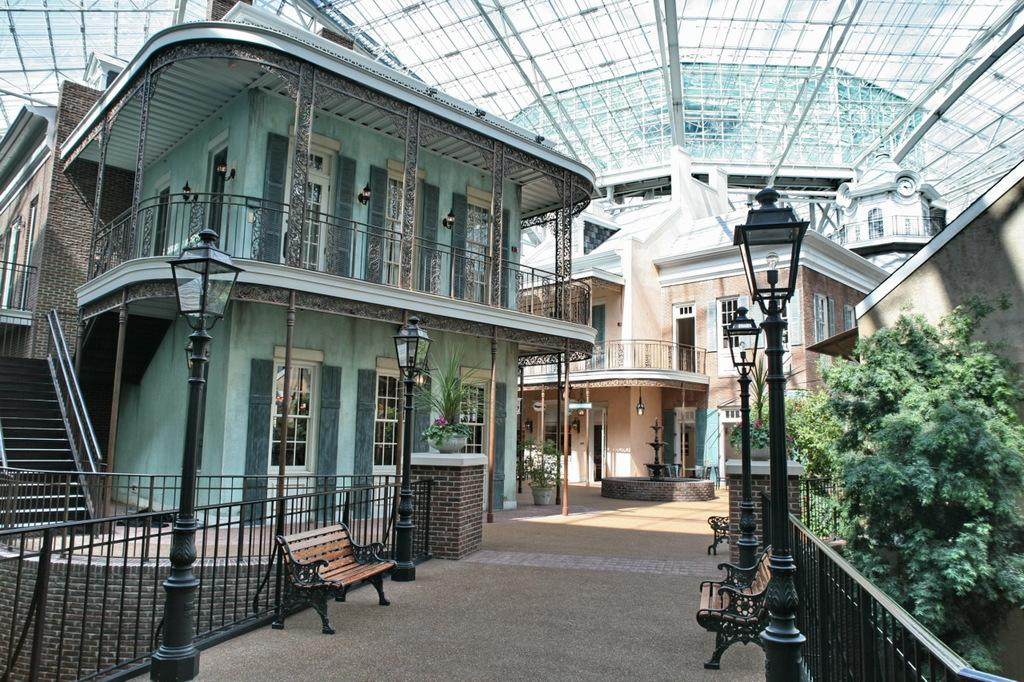What type of seating is visible in the image? There are benches in the image. What structures can be seen on the ground in the image? There are poles on the ground in the image. What type of barrier is present in the image? There is a fence in the image. What type of plants are visible in the image? There are house plants and trees in the image. What type of water feature is present in the image? There is a fountain in the image. What architectural feature is present in the image? There are steps in the image. What type of buildings can be seen in the background of the image? In the background, there are buildings with windows and doors. How many sheep are present in the image? There are no sheep present in the image. What type of feast is being held in the image? There is no feast present in the image. 